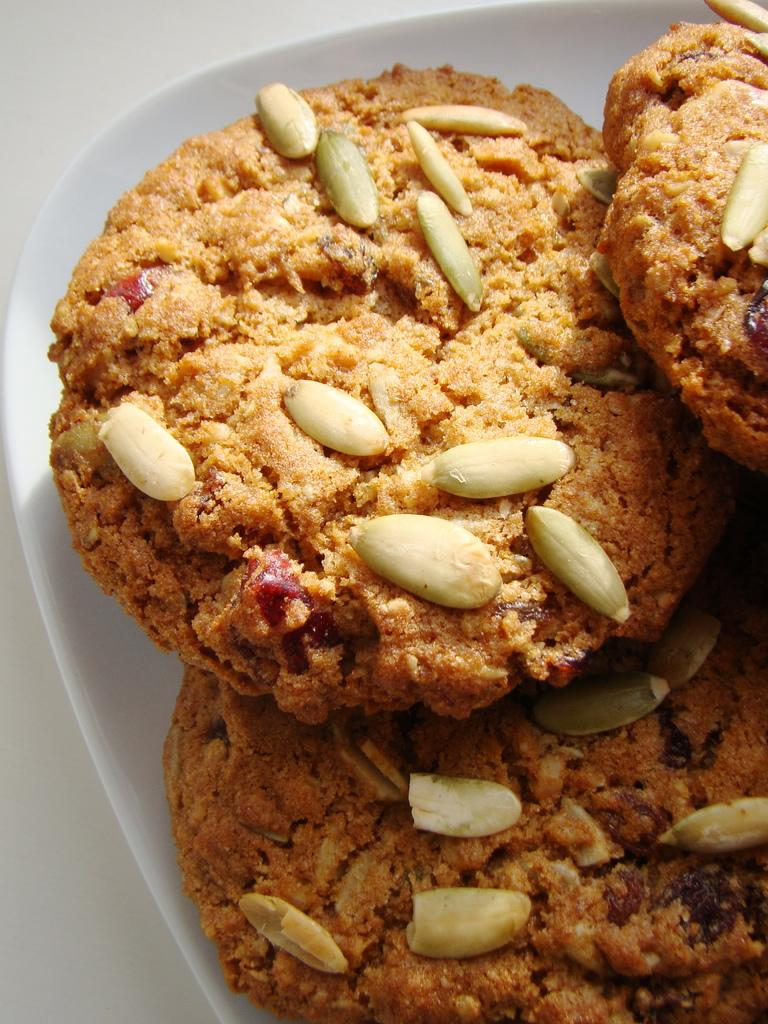How many cookies are visible in the image? There are three cookies in the image. Where are the cookies placed? The cookies are on a plate. What is the plate resting on? The plate is on a platform. What type of sign can be seen on the cookies in the image? There are no signs visible on the cookies in the image. Is there a horse present in the image? No, there is no horse present in the image. 